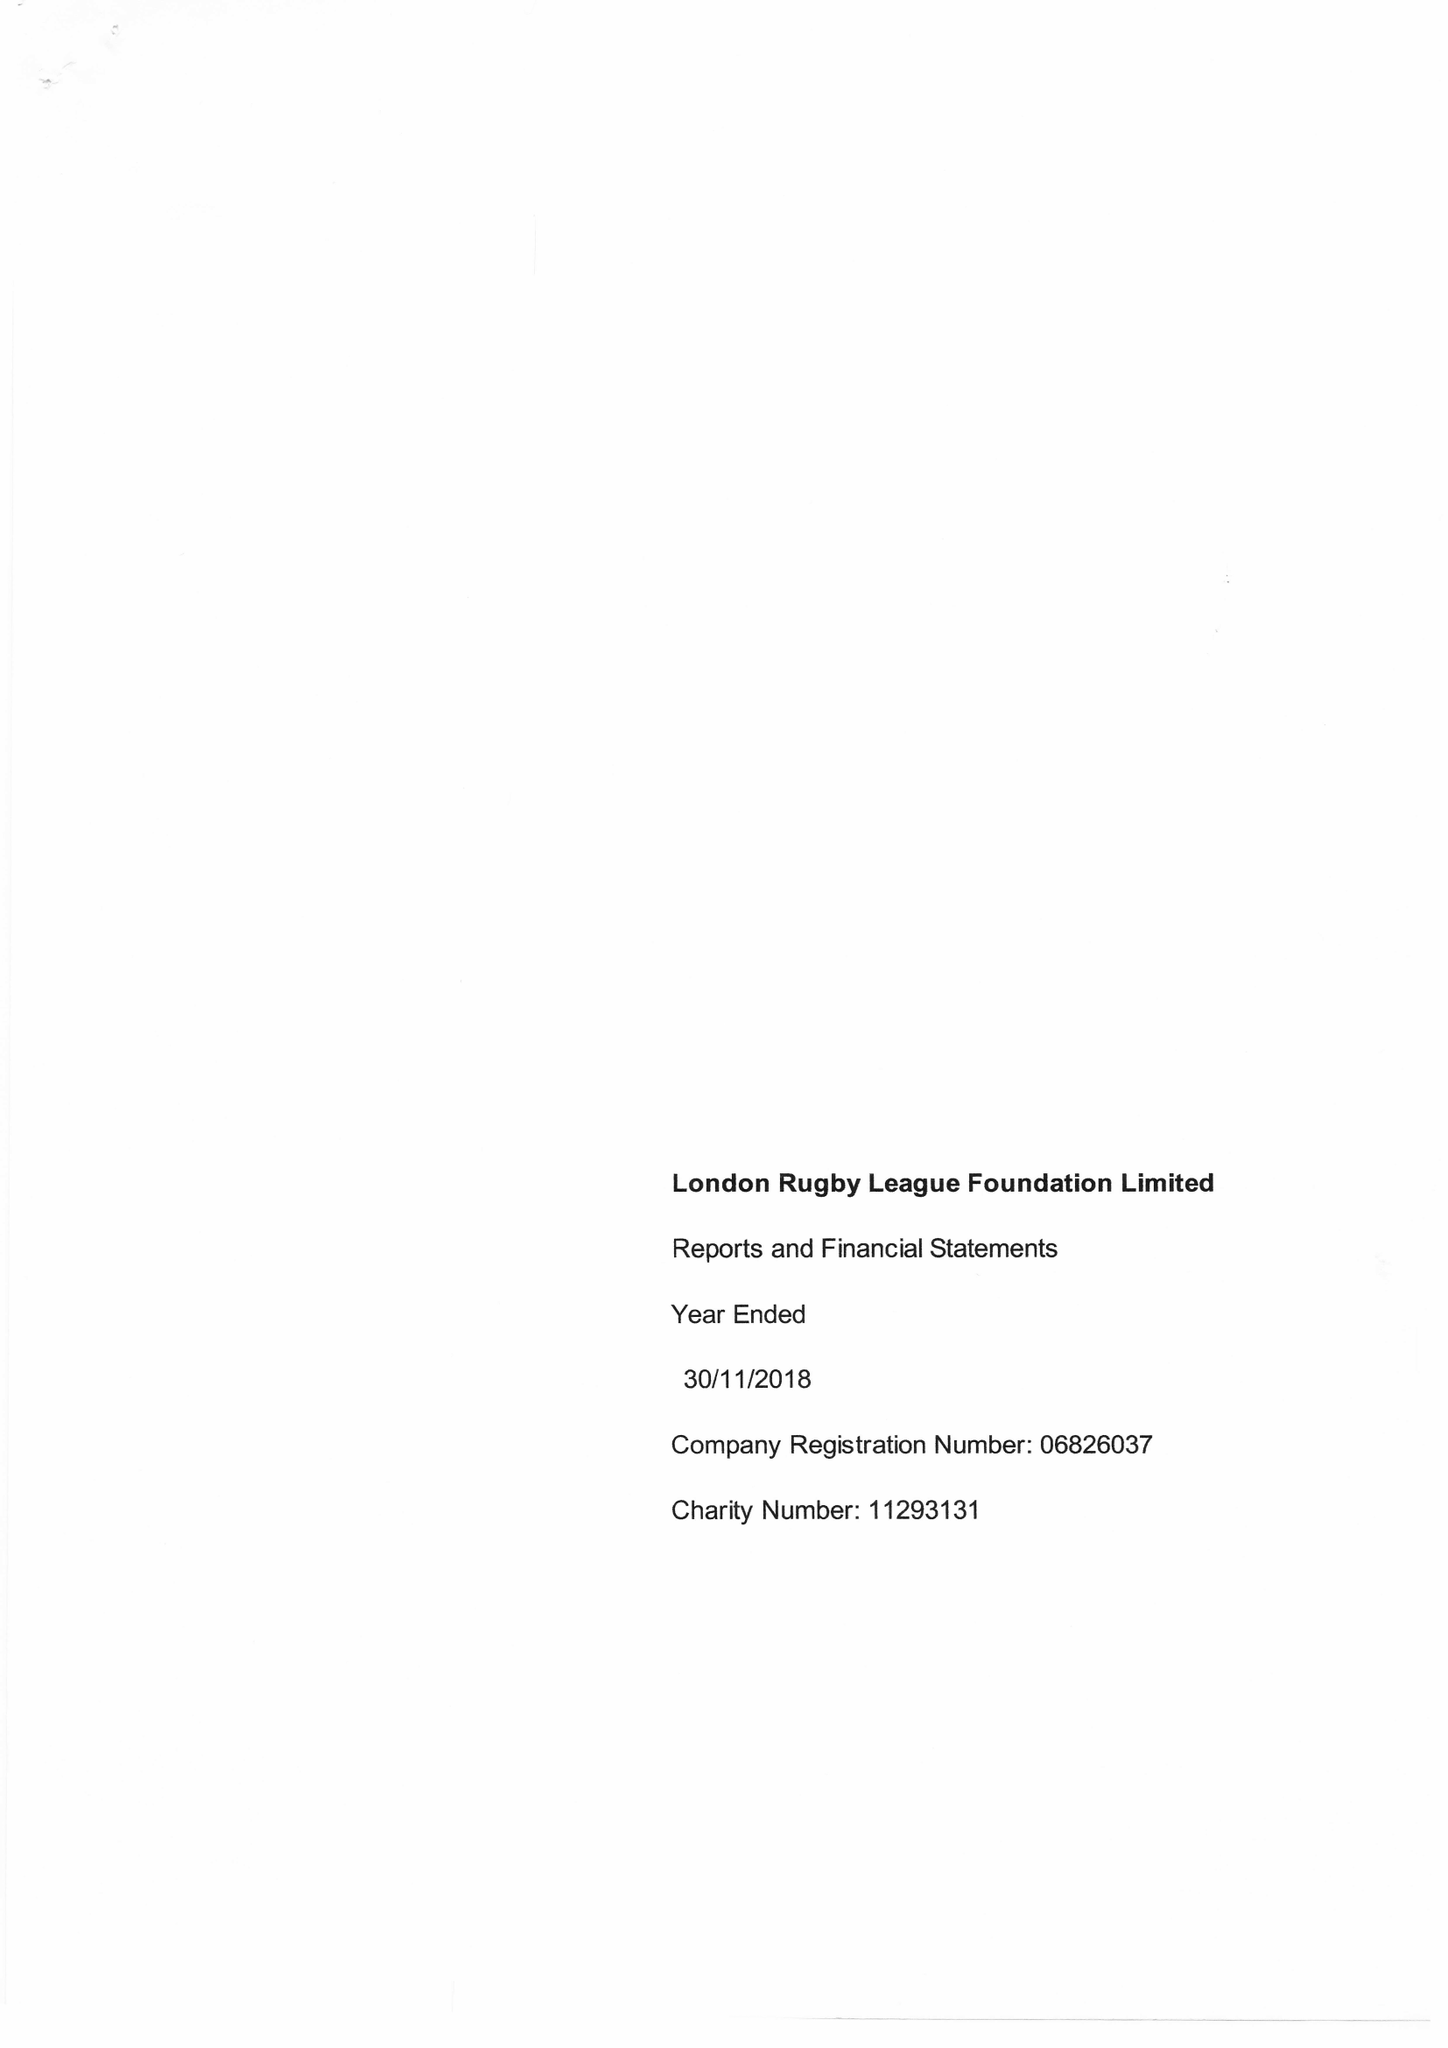What is the value for the income_annually_in_british_pounds?
Answer the question using a single word or phrase. 141354.00 